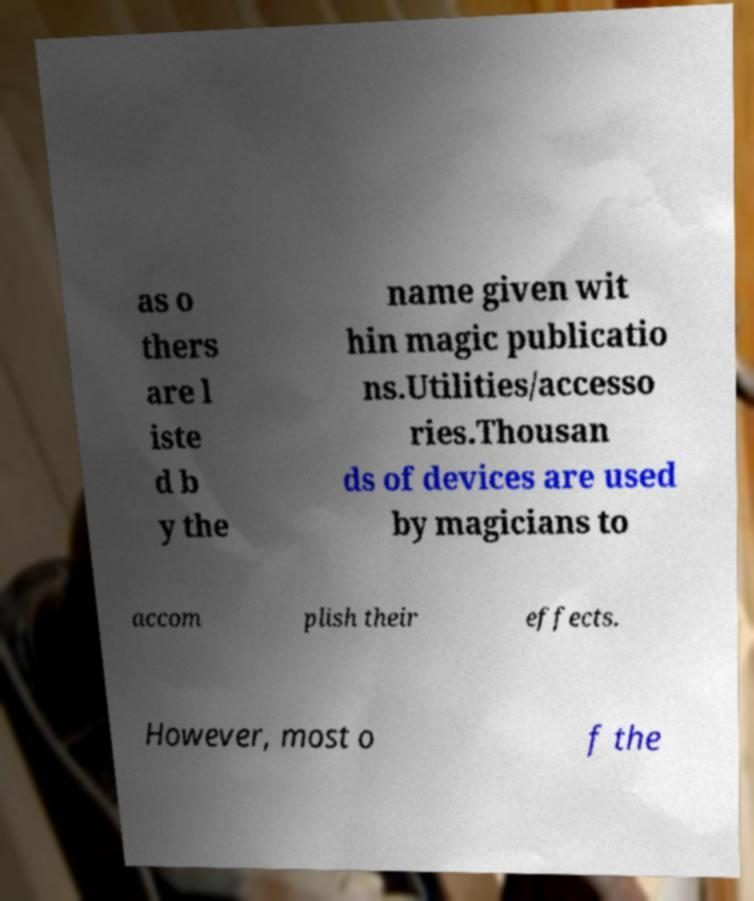Could you assist in decoding the text presented in this image and type it out clearly? as o thers are l iste d b y the name given wit hin magic publicatio ns.Utilities/accesso ries.Thousan ds of devices are used by magicians to accom plish their effects. However, most o f the 